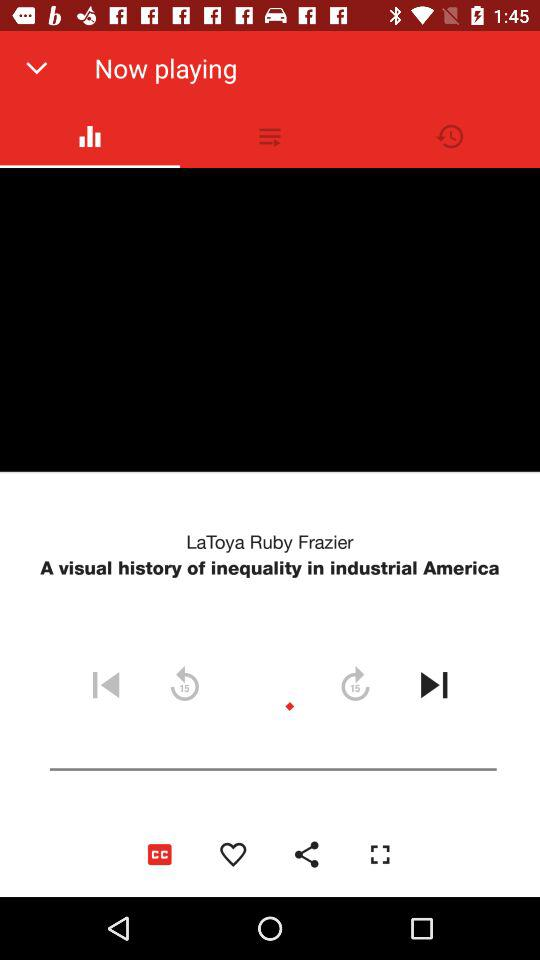What is the title of the TED talk that is about to be played? The title of the TED talk that is about to be played is "A visual history of inequality in industrial America". 